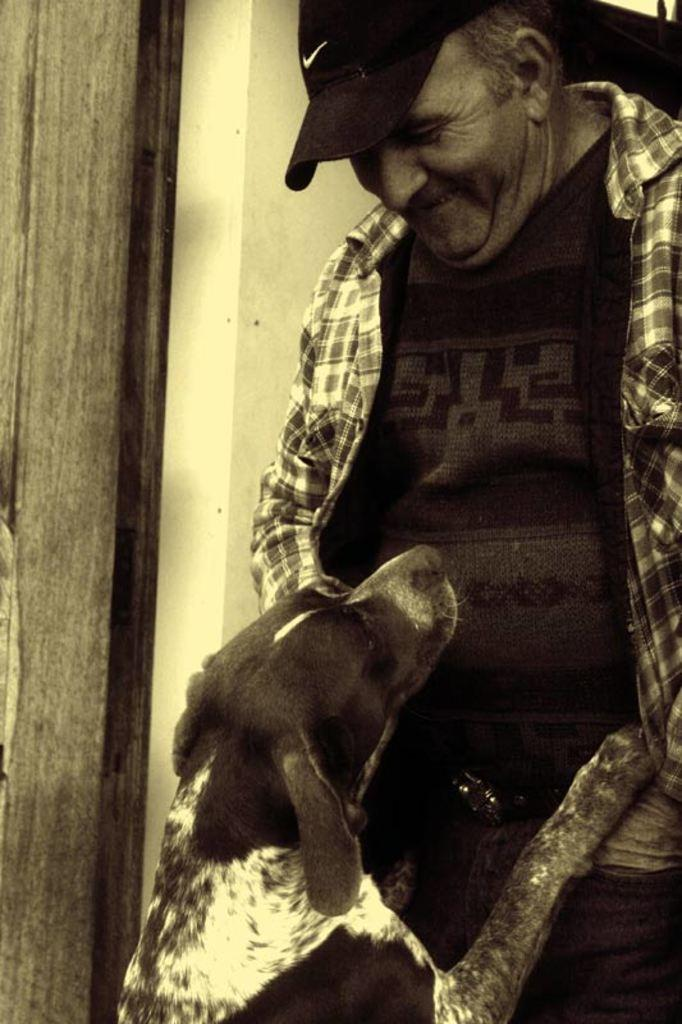What is the man in the image wearing? The man is wearing a black t-shirt and a checked shirt. What accessory is the man wearing on his head? The man is wearing a cap. What is the man's facial expression in the image? The man is smiling. What animal is standing on the man in the image? There is a dog standing on the man. What can be seen in the left corner of the image? There is a wood in the left corner of the image. What type of news can be heard coming from the bells in the image? There are no bells present in the image, so it's not possible to determine what, if any, news might be heard. What type of potato is visible in the image? There is no potato present in the image. 